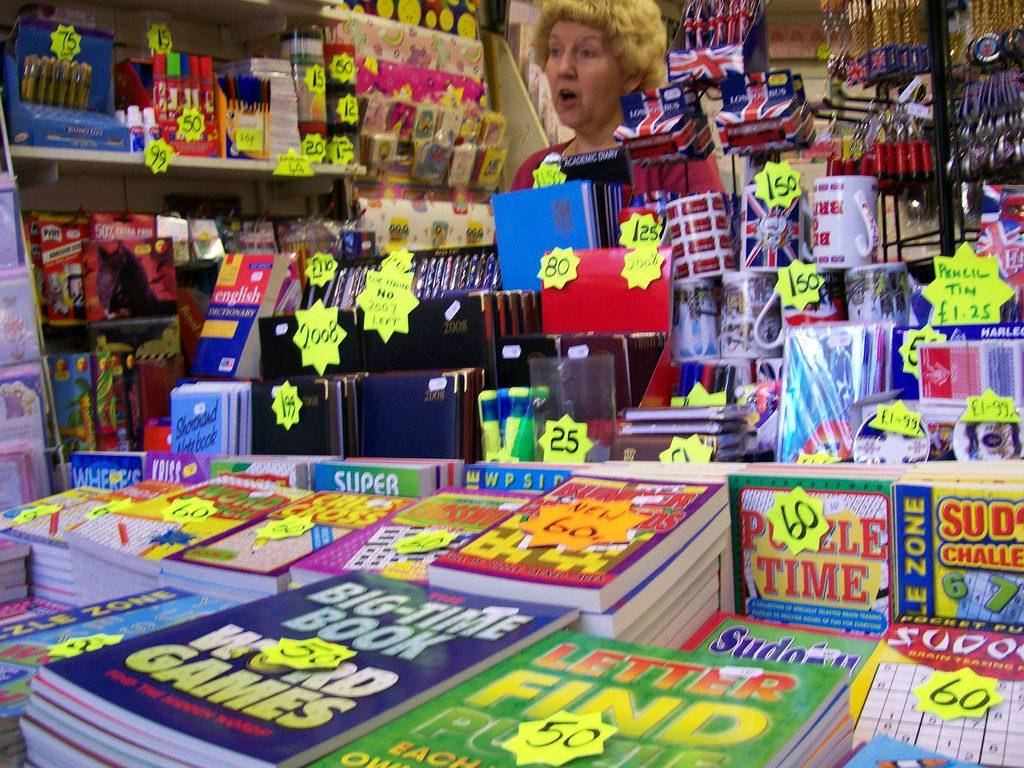<image>
Offer a succinct explanation of the picture presented. A shop display of journals and game books, including The Big-Time Book of Word Games. 